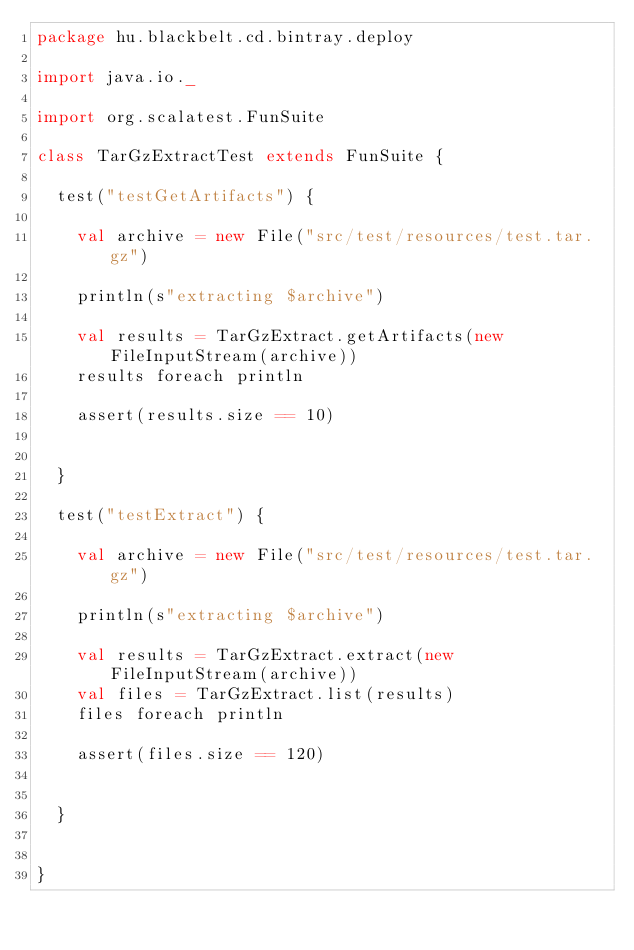Convert code to text. <code><loc_0><loc_0><loc_500><loc_500><_Scala_>package hu.blackbelt.cd.bintray.deploy

import java.io._

import org.scalatest.FunSuite

class TarGzExtractTest extends FunSuite {

  test("testGetArtifacts") {

    val archive = new File("src/test/resources/test.tar.gz")

    println(s"extracting $archive")

    val results = TarGzExtract.getArtifacts(new FileInputStream(archive))
    results foreach println

    assert(results.size == 10)


  }

  test("testExtract") {

    val archive = new File("src/test/resources/test.tar.gz")

    println(s"extracting $archive")

    val results = TarGzExtract.extract(new FileInputStream(archive))
    val files = TarGzExtract.list(results)
    files foreach println

    assert(files.size == 120)


  }


}
</code> 